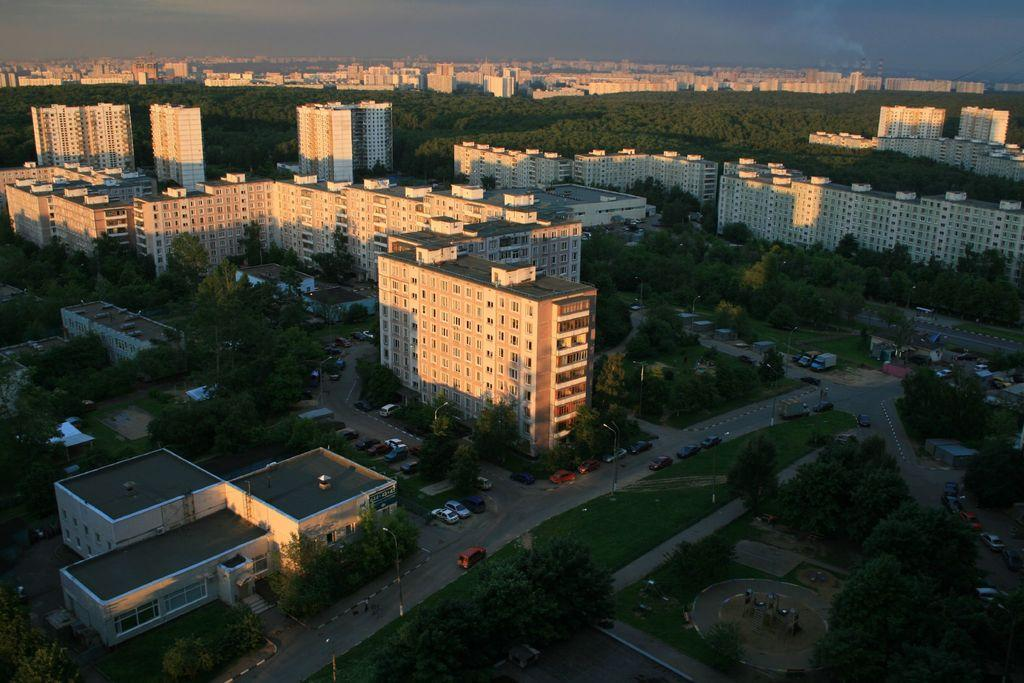What type of structures can be seen in the image? There are buildings with windows in the image. What is happening on the road in the image? There are vehicles on the road in the image. What type of vegetation is present in the image? There are trees in the image. What else can be seen in the image besides buildings, vehicles, and trees? There are poles in the image. What is visible in the background of the image? The sky with clouds is visible in the background of the image. What type of account is being discussed in the image? There is no account being discussed in the image; it features buildings, vehicles, trees, poles, and a sky with clouds. Are there any stockings visible in the image? There are no stockings present in the image. 